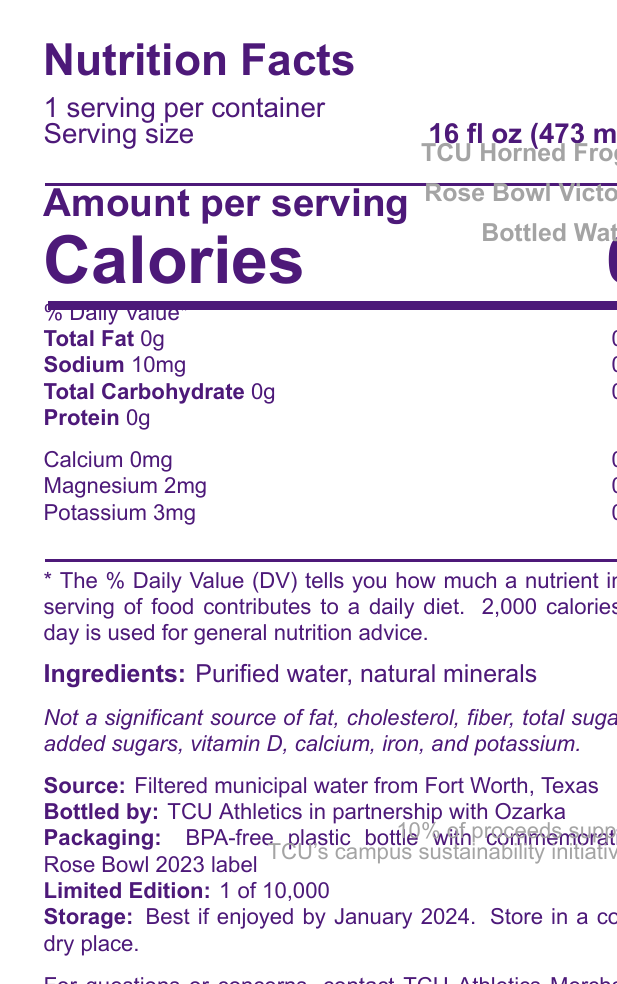what is the serving size of the TCU Horned Frogs Rose Bowl Victory bottled water? The serving size is clearly listed as "16 fl oz (473 mL)" on the document.
Answer: 16 fl oz (473 mL) how much sodium does each serving of the bottled water contain? The document states that the sodium content per serving is 10mg.
Answer: 10mg what are the ingredients in this bottled water? The ingredients are explicitly mentioned as "Purified water, natural minerals".
Answer: Purified water, natural minerals is this bottled water a significant source of calcium? The document notes that it is "Not a significant source of calcium" and also lists the calcium content as 0mg.
Answer: No who bottled this commemorative water? The bottling information is given as "Bottled by: TCU Athletics in partnership with Ozarka".
Answer: TCU Athletics in partnership with Ozarka what minerals are present in the bottled water? The document lists the minerals as magnesium (2mg) and potassium (3mg).
Answer: Magnesium and potassium which city provided the source water for this product? The source is indicated as "Filtered municipal water from Fort Worth, Texas".
Answer: Fort Worth, Texas what is indicated by the "limited edition" status of this product? The document specifies that this is a "Limited Edition: 1 of 10,000".
Answer: 1 of 10,000 how is the packaging of this bottled water described? The packaging is described in the document with details about the BPA-free plastic and the Rose Bowl 2023 label.
Answer: BPA-free plastic bottle with commemorative Rose Bowl 2023 label for how long is this product best enjoyed? The storage information states that the product is best if enjoyed by January 2024.
Answer: Best if enjoyed by January 2024 what is the design of the bottle? A. Green bottle with gold TCU logo B. Purple bottle with silver TCU logo C. Blue bottle with white TCU logo D. Black bottle with silver TCU logo The design is described as a "Purple bottle with silver TCU logo and Rose Bowl trophy graphic".
Answer: B how much of the proceeds support TCU's campus sustainability initiatives? A. 5% B. 10% C. 15% D. 20% The document states that 10% of proceeds support TCU's campus sustainability initiatives.
Answer: B does this bottled water contain any calories? The document indicates that there are 0 calories per serving.
Answer: No summarize the main features of this TCU Horned Frogs Rose Bowl Victory bottled water. This summary encompasses the key points mentioned in the document including the product's commemorative nature, design, source, and purpose.
Answer: This is a limited-edition bottled water commemorating TCU's Rose Bowl victory, featuring a purple bottle emblazoned with the TCU logo and Rose Bowl trophy graphic. It is bottled by TCU Athletics in partnership with Ozarka using filtered municipal water from Fort Worth, Texas, and contains purified water with natural minerals. The bottle is BPA-free, and 10% of proceeds support TCU's campus sustainability initiatives. what is the QR code on the bottle linked to? The document specifies the presence of a QR code linking to a highlight reel of TCU's Rose Bowl victory, but the exact link or type of content it leads to isn't provided in the visual information.
Answer: Not enough information 